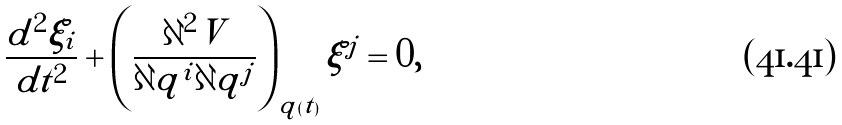Convert formula to latex. <formula><loc_0><loc_0><loc_500><loc_500>\frac { d ^ { 2 } \xi _ { i } } { d t ^ { 2 } } + \left ( \frac { \partial ^ { 2 } V } { \partial q ^ { i } \partial q ^ { j } } \right ) _ { q ( t ) } \xi ^ { j } = 0 ,</formula> 